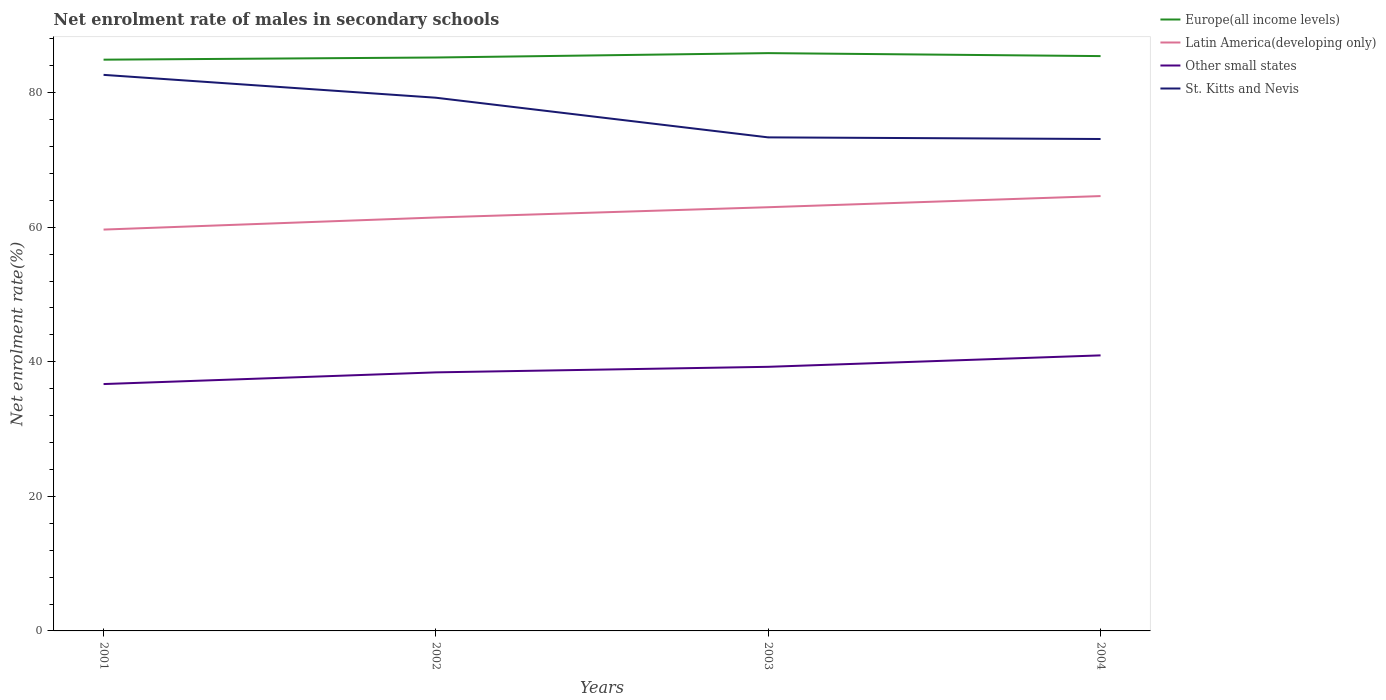Across all years, what is the maximum net enrolment rate of males in secondary schools in Other small states?
Provide a short and direct response. 36.69. In which year was the net enrolment rate of males in secondary schools in St. Kitts and Nevis maximum?
Offer a terse response. 2004. What is the total net enrolment rate of males in secondary schools in Latin America(developing only) in the graph?
Ensure brevity in your answer.  -1.66. What is the difference between the highest and the second highest net enrolment rate of males in secondary schools in Latin America(developing only)?
Your answer should be very brief. 4.98. What is the difference between the highest and the lowest net enrolment rate of males in secondary schools in Other small states?
Provide a short and direct response. 2. Is the net enrolment rate of males in secondary schools in Other small states strictly greater than the net enrolment rate of males in secondary schools in Europe(all income levels) over the years?
Your answer should be compact. Yes. How many lines are there?
Offer a very short reply. 4. How many years are there in the graph?
Give a very brief answer. 4. What is the difference between two consecutive major ticks on the Y-axis?
Keep it short and to the point. 20. Does the graph contain grids?
Provide a short and direct response. No. Where does the legend appear in the graph?
Keep it short and to the point. Top right. How are the legend labels stacked?
Give a very brief answer. Vertical. What is the title of the graph?
Give a very brief answer. Net enrolment rate of males in secondary schools. What is the label or title of the Y-axis?
Make the answer very short. Net enrolment rate(%). What is the Net enrolment rate(%) of Europe(all income levels) in 2001?
Give a very brief answer. 84.9. What is the Net enrolment rate(%) of Latin America(developing only) in 2001?
Your answer should be compact. 59.65. What is the Net enrolment rate(%) of Other small states in 2001?
Provide a succinct answer. 36.69. What is the Net enrolment rate(%) of St. Kitts and Nevis in 2001?
Provide a succinct answer. 82.65. What is the Net enrolment rate(%) of Europe(all income levels) in 2002?
Provide a succinct answer. 85.23. What is the Net enrolment rate(%) of Latin America(developing only) in 2002?
Give a very brief answer. 61.45. What is the Net enrolment rate(%) in Other small states in 2002?
Make the answer very short. 38.43. What is the Net enrolment rate(%) of St. Kitts and Nevis in 2002?
Your response must be concise. 79.25. What is the Net enrolment rate(%) of Europe(all income levels) in 2003?
Your answer should be compact. 85.88. What is the Net enrolment rate(%) of Latin America(developing only) in 2003?
Keep it short and to the point. 62.97. What is the Net enrolment rate(%) of Other small states in 2003?
Provide a succinct answer. 39.26. What is the Net enrolment rate(%) in St. Kitts and Nevis in 2003?
Your response must be concise. 73.36. What is the Net enrolment rate(%) of Europe(all income levels) in 2004?
Provide a short and direct response. 85.44. What is the Net enrolment rate(%) of Latin America(developing only) in 2004?
Give a very brief answer. 64.63. What is the Net enrolment rate(%) in Other small states in 2004?
Ensure brevity in your answer.  40.96. What is the Net enrolment rate(%) in St. Kitts and Nevis in 2004?
Your answer should be very brief. 73.11. Across all years, what is the maximum Net enrolment rate(%) in Europe(all income levels)?
Offer a very short reply. 85.88. Across all years, what is the maximum Net enrolment rate(%) in Latin America(developing only)?
Make the answer very short. 64.63. Across all years, what is the maximum Net enrolment rate(%) in Other small states?
Your answer should be very brief. 40.96. Across all years, what is the maximum Net enrolment rate(%) of St. Kitts and Nevis?
Provide a short and direct response. 82.65. Across all years, what is the minimum Net enrolment rate(%) in Europe(all income levels)?
Your answer should be compact. 84.9. Across all years, what is the minimum Net enrolment rate(%) of Latin America(developing only)?
Your answer should be very brief. 59.65. Across all years, what is the minimum Net enrolment rate(%) in Other small states?
Give a very brief answer. 36.69. Across all years, what is the minimum Net enrolment rate(%) in St. Kitts and Nevis?
Your response must be concise. 73.11. What is the total Net enrolment rate(%) in Europe(all income levels) in the graph?
Your response must be concise. 341.45. What is the total Net enrolment rate(%) in Latin America(developing only) in the graph?
Ensure brevity in your answer.  248.71. What is the total Net enrolment rate(%) in Other small states in the graph?
Your response must be concise. 155.33. What is the total Net enrolment rate(%) in St. Kitts and Nevis in the graph?
Your answer should be compact. 308.37. What is the difference between the Net enrolment rate(%) of Europe(all income levels) in 2001 and that in 2002?
Your response must be concise. -0.32. What is the difference between the Net enrolment rate(%) of Latin America(developing only) in 2001 and that in 2002?
Make the answer very short. -1.8. What is the difference between the Net enrolment rate(%) in Other small states in 2001 and that in 2002?
Provide a succinct answer. -1.74. What is the difference between the Net enrolment rate(%) in St. Kitts and Nevis in 2001 and that in 2002?
Provide a succinct answer. 3.4. What is the difference between the Net enrolment rate(%) in Europe(all income levels) in 2001 and that in 2003?
Your answer should be compact. -0.97. What is the difference between the Net enrolment rate(%) of Latin America(developing only) in 2001 and that in 2003?
Keep it short and to the point. -3.32. What is the difference between the Net enrolment rate(%) in Other small states in 2001 and that in 2003?
Ensure brevity in your answer.  -2.56. What is the difference between the Net enrolment rate(%) of St. Kitts and Nevis in 2001 and that in 2003?
Your answer should be very brief. 9.29. What is the difference between the Net enrolment rate(%) of Europe(all income levels) in 2001 and that in 2004?
Make the answer very short. -0.53. What is the difference between the Net enrolment rate(%) of Latin America(developing only) in 2001 and that in 2004?
Offer a terse response. -4.98. What is the difference between the Net enrolment rate(%) in Other small states in 2001 and that in 2004?
Give a very brief answer. -4.26. What is the difference between the Net enrolment rate(%) in St. Kitts and Nevis in 2001 and that in 2004?
Make the answer very short. 9.53. What is the difference between the Net enrolment rate(%) of Europe(all income levels) in 2002 and that in 2003?
Keep it short and to the point. -0.65. What is the difference between the Net enrolment rate(%) of Latin America(developing only) in 2002 and that in 2003?
Ensure brevity in your answer.  -1.52. What is the difference between the Net enrolment rate(%) in Other small states in 2002 and that in 2003?
Keep it short and to the point. -0.83. What is the difference between the Net enrolment rate(%) of St. Kitts and Nevis in 2002 and that in 2003?
Your answer should be compact. 5.89. What is the difference between the Net enrolment rate(%) in Europe(all income levels) in 2002 and that in 2004?
Keep it short and to the point. -0.21. What is the difference between the Net enrolment rate(%) in Latin America(developing only) in 2002 and that in 2004?
Provide a succinct answer. -3.18. What is the difference between the Net enrolment rate(%) of Other small states in 2002 and that in 2004?
Keep it short and to the point. -2.53. What is the difference between the Net enrolment rate(%) of St. Kitts and Nevis in 2002 and that in 2004?
Give a very brief answer. 6.14. What is the difference between the Net enrolment rate(%) of Europe(all income levels) in 2003 and that in 2004?
Give a very brief answer. 0.44. What is the difference between the Net enrolment rate(%) in Latin America(developing only) in 2003 and that in 2004?
Keep it short and to the point. -1.66. What is the difference between the Net enrolment rate(%) of Other small states in 2003 and that in 2004?
Your answer should be very brief. -1.7. What is the difference between the Net enrolment rate(%) in St. Kitts and Nevis in 2003 and that in 2004?
Keep it short and to the point. 0.24. What is the difference between the Net enrolment rate(%) of Europe(all income levels) in 2001 and the Net enrolment rate(%) of Latin America(developing only) in 2002?
Provide a short and direct response. 23.45. What is the difference between the Net enrolment rate(%) of Europe(all income levels) in 2001 and the Net enrolment rate(%) of Other small states in 2002?
Give a very brief answer. 46.48. What is the difference between the Net enrolment rate(%) of Europe(all income levels) in 2001 and the Net enrolment rate(%) of St. Kitts and Nevis in 2002?
Make the answer very short. 5.66. What is the difference between the Net enrolment rate(%) in Latin America(developing only) in 2001 and the Net enrolment rate(%) in Other small states in 2002?
Provide a succinct answer. 21.22. What is the difference between the Net enrolment rate(%) of Latin America(developing only) in 2001 and the Net enrolment rate(%) of St. Kitts and Nevis in 2002?
Ensure brevity in your answer.  -19.6. What is the difference between the Net enrolment rate(%) of Other small states in 2001 and the Net enrolment rate(%) of St. Kitts and Nevis in 2002?
Ensure brevity in your answer.  -42.56. What is the difference between the Net enrolment rate(%) of Europe(all income levels) in 2001 and the Net enrolment rate(%) of Latin America(developing only) in 2003?
Your answer should be compact. 21.93. What is the difference between the Net enrolment rate(%) of Europe(all income levels) in 2001 and the Net enrolment rate(%) of Other small states in 2003?
Offer a terse response. 45.65. What is the difference between the Net enrolment rate(%) of Europe(all income levels) in 2001 and the Net enrolment rate(%) of St. Kitts and Nevis in 2003?
Offer a terse response. 11.55. What is the difference between the Net enrolment rate(%) in Latin America(developing only) in 2001 and the Net enrolment rate(%) in Other small states in 2003?
Offer a very short reply. 20.4. What is the difference between the Net enrolment rate(%) of Latin America(developing only) in 2001 and the Net enrolment rate(%) of St. Kitts and Nevis in 2003?
Provide a short and direct response. -13.7. What is the difference between the Net enrolment rate(%) of Other small states in 2001 and the Net enrolment rate(%) of St. Kitts and Nevis in 2003?
Provide a succinct answer. -36.66. What is the difference between the Net enrolment rate(%) in Europe(all income levels) in 2001 and the Net enrolment rate(%) in Latin America(developing only) in 2004?
Your response must be concise. 20.27. What is the difference between the Net enrolment rate(%) in Europe(all income levels) in 2001 and the Net enrolment rate(%) in Other small states in 2004?
Your answer should be compact. 43.95. What is the difference between the Net enrolment rate(%) in Europe(all income levels) in 2001 and the Net enrolment rate(%) in St. Kitts and Nevis in 2004?
Your answer should be compact. 11.79. What is the difference between the Net enrolment rate(%) of Latin America(developing only) in 2001 and the Net enrolment rate(%) of Other small states in 2004?
Ensure brevity in your answer.  18.7. What is the difference between the Net enrolment rate(%) in Latin America(developing only) in 2001 and the Net enrolment rate(%) in St. Kitts and Nevis in 2004?
Keep it short and to the point. -13.46. What is the difference between the Net enrolment rate(%) of Other small states in 2001 and the Net enrolment rate(%) of St. Kitts and Nevis in 2004?
Ensure brevity in your answer.  -36.42. What is the difference between the Net enrolment rate(%) in Europe(all income levels) in 2002 and the Net enrolment rate(%) in Latin America(developing only) in 2003?
Make the answer very short. 22.25. What is the difference between the Net enrolment rate(%) in Europe(all income levels) in 2002 and the Net enrolment rate(%) in Other small states in 2003?
Give a very brief answer. 45.97. What is the difference between the Net enrolment rate(%) of Europe(all income levels) in 2002 and the Net enrolment rate(%) of St. Kitts and Nevis in 2003?
Your answer should be compact. 11.87. What is the difference between the Net enrolment rate(%) in Latin America(developing only) in 2002 and the Net enrolment rate(%) in Other small states in 2003?
Offer a very short reply. 22.19. What is the difference between the Net enrolment rate(%) of Latin America(developing only) in 2002 and the Net enrolment rate(%) of St. Kitts and Nevis in 2003?
Your answer should be very brief. -11.91. What is the difference between the Net enrolment rate(%) of Other small states in 2002 and the Net enrolment rate(%) of St. Kitts and Nevis in 2003?
Give a very brief answer. -34.93. What is the difference between the Net enrolment rate(%) in Europe(all income levels) in 2002 and the Net enrolment rate(%) in Latin America(developing only) in 2004?
Your answer should be compact. 20.6. What is the difference between the Net enrolment rate(%) of Europe(all income levels) in 2002 and the Net enrolment rate(%) of Other small states in 2004?
Provide a succinct answer. 44.27. What is the difference between the Net enrolment rate(%) of Europe(all income levels) in 2002 and the Net enrolment rate(%) of St. Kitts and Nevis in 2004?
Your response must be concise. 12.11. What is the difference between the Net enrolment rate(%) of Latin America(developing only) in 2002 and the Net enrolment rate(%) of Other small states in 2004?
Ensure brevity in your answer.  20.5. What is the difference between the Net enrolment rate(%) of Latin America(developing only) in 2002 and the Net enrolment rate(%) of St. Kitts and Nevis in 2004?
Offer a terse response. -11.66. What is the difference between the Net enrolment rate(%) in Other small states in 2002 and the Net enrolment rate(%) in St. Kitts and Nevis in 2004?
Your answer should be compact. -34.68. What is the difference between the Net enrolment rate(%) of Europe(all income levels) in 2003 and the Net enrolment rate(%) of Latin America(developing only) in 2004?
Your answer should be compact. 21.25. What is the difference between the Net enrolment rate(%) of Europe(all income levels) in 2003 and the Net enrolment rate(%) of Other small states in 2004?
Keep it short and to the point. 44.92. What is the difference between the Net enrolment rate(%) of Europe(all income levels) in 2003 and the Net enrolment rate(%) of St. Kitts and Nevis in 2004?
Offer a terse response. 12.76. What is the difference between the Net enrolment rate(%) of Latin America(developing only) in 2003 and the Net enrolment rate(%) of Other small states in 2004?
Ensure brevity in your answer.  22.02. What is the difference between the Net enrolment rate(%) in Latin America(developing only) in 2003 and the Net enrolment rate(%) in St. Kitts and Nevis in 2004?
Offer a very short reply. -10.14. What is the difference between the Net enrolment rate(%) in Other small states in 2003 and the Net enrolment rate(%) in St. Kitts and Nevis in 2004?
Offer a terse response. -33.86. What is the average Net enrolment rate(%) in Europe(all income levels) per year?
Your answer should be very brief. 85.36. What is the average Net enrolment rate(%) of Latin America(developing only) per year?
Keep it short and to the point. 62.18. What is the average Net enrolment rate(%) in Other small states per year?
Your answer should be very brief. 38.83. What is the average Net enrolment rate(%) in St. Kitts and Nevis per year?
Make the answer very short. 77.09. In the year 2001, what is the difference between the Net enrolment rate(%) in Europe(all income levels) and Net enrolment rate(%) in Latin America(developing only)?
Your response must be concise. 25.25. In the year 2001, what is the difference between the Net enrolment rate(%) in Europe(all income levels) and Net enrolment rate(%) in Other small states?
Offer a terse response. 48.21. In the year 2001, what is the difference between the Net enrolment rate(%) of Europe(all income levels) and Net enrolment rate(%) of St. Kitts and Nevis?
Your answer should be compact. 2.26. In the year 2001, what is the difference between the Net enrolment rate(%) in Latin America(developing only) and Net enrolment rate(%) in Other small states?
Your response must be concise. 22.96. In the year 2001, what is the difference between the Net enrolment rate(%) in Latin America(developing only) and Net enrolment rate(%) in St. Kitts and Nevis?
Give a very brief answer. -23. In the year 2001, what is the difference between the Net enrolment rate(%) in Other small states and Net enrolment rate(%) in St. Kitts and Nevis?
Your response must be concise. -45.96. In the year 2002, what is the difference between the Net enrolment rate(%) of Europe(all income levels) and Net enrolment rate(%) of Latin America(developing only)?
Your response must be concise. 23.78. In the year 2002, what is the difference between the Net enrolment rate(%) in Europe(all income levels) and Net enrolment rate(%) in Other small states?
Provide a short and direct response. 46.8. In the year 2002, what is the difference between the Net enrolment rate(%) of Europe(all income levels) and Net enrolment rate(%) of St. Kitts and Nevis?
Make the answer very short. 5.98. In the year 2002, what is the difference between the Net enrolment rate(%) of Latin America(developing only) and Net enrolment rate(%) of Other small states?
Your answer should be compact. 23.02. In the year 2002, what is the difference between the Net enrolment rate(%) of Latin America(developing only) and Net enrolment rate(%) of St. Kitts and Nevis?
Your answer should be very brief. -17.8. In the year 2002, what is the difference between the Net enrolment rate(%) in Other small states and Net enrolment rate(%) in St. Kitts and Nevis?
Your response must be concise. -40.82. In the year 2003, what is the difference between the Net enrolment rate(%) of Europe(all income levels) and Net enrolment rate(%) of Latin America(developing only)?
Your answer should be very brief. 22.9. In the year 2003, what is the difference between the Net enrolment rate(%) of Europe(all income levels) and Net enrolment rate(%) of Other small states?
Your response must be concise. 46.62. In the year 2003, what is the difference between the Net enrolment rate(%) of Europe(all income levels) and Net enrolment rate(%) of St. Kitts and Nevis?
Make the answer very short. 12.52. In the year 2003, what is the difference between the Net enrolment rate(%) in Latin America(developing only) and Net enrolment rate(%) in Other small states?
Your answer should be very brief. 23.72. In the year 2003, what is the difference between the Net enrolment rate(%) in Latin America(developing only) and Net enrolment rate(%) in St. Kitts and Nevis?
Make the answer very short. -10.38. In the year 2003, what is the difference between the Net enrolment rate(%) of Other small states and Net enrolment rate(%) of St. Kitts and Nevis?
Offer a very short reply. -34.1. In the year 2004, what is the difference between the Net enrolment rate(%) in Europe(all income levels) and Net enrolment rate(%) in Latin America(developing only)?
Keep it short and to the point. 20.81. In the year 2004, what is the difference between the Net enrolment rate(%) in Europe(all income levels) and Net enrolment rate(%) in Other small states?
Ensure brevity in your answer.  44.48. In the year 2004, what is the difference between the Net enrolment rate(%) in Europe(all income levels) and Net enrolment rate(%) in St. Kitts and Nevis?
Your answer should be very brief. 12.32. In the year 2004, what is the difference between the Net enrolment rate(%) in Latin America(developing only) and Net enrolment rate(%) in Other small states?
Ensure brevity in your answer.  23.68. In the year 2004, what is the difference between the Net enrolment rate(%) in Latin America(developing only) and Net enrolment rate(%) in St. Kitts and Nevis?
Provide a short and direct response. -8.48. In the year 2004, what is the difference between the Net enrolment rate(%) of Other small states and Net enrolment rate(%) of St. Kitts and Nevis?
Offer a very short reply. -32.16. What is the ratio of the Net enrolment rate(%) of Europe(all income levels) in 2001 to that in 2002?
Your answer should be very brief. 1. What is the ratio of the Net enrolment rate(%) in Latin America(developing only) in 2001 to that in 2002?
Provide a succinct answer. 0.97. What is the ratio of the Net enrolment rate(%) in Other small states in 2001 to that in 2002?
Offer a very short reply. 0.95. What is the ratio of the Net enrolment rate(%) in St. Kitts and Nevis in 2001 to that in 2002?
Your answer should be compact. 1.04. What is the ratio of the Net enrolment rate(%) of Europe(all income levels) in 2001 to that in 2003?
Provide a succinct answer. 0.99. What is the ratio of the Net enrolment rate(%) in Latin America(developing only) in 2001 to that in 2003?
Ensure brevity in your answer.  0.95. What is the ratio of the Net enrolment rate(%) of Other small states in 2001 to that in 2003?
Ensure brevity in your answer.  0.93. What is the ratio of the Net enrolment rate(%) in St. Kitts and Nevis in 2001 to that in 2003?
Provide a succinct answer. 1.13. What is the ratio of the Net enrolment rate(%) in Europe(all income levels) in 2001 to that in 2004?
Offer a very short reply. 0.99. What is the ratio of the Net enrolment rate(%) in Latin America(developing only) in 2001 to that in 2004?
Keep it short and to the point. 0.92. What is the ratio of the Net enrolment rate(%) of Other small states in 2001 to that in 2004?
Offer a terse response. 0.9. What is the ratio of the Net enrolment rate(%) of St. Kitts and Nevis in 2001 to that in 2004?
Offer a terse response. 1.13. What is the ratio of the Net enrolment rate(%) in Europe(all income levels) in 2002 to that in 2003?
Offer a very short reply. 0.99. What is the ratio of the Net enrolment rate(%) in Latin America(developing only) in 2002 to that in 2003?
Ensure brevity in your answer.  0.98. What is the ratio of the Net enrolment rate(%) in Other small states in 2002 to that in 2003?
Give a very brief answer. 0.98. What is the ratio of the Net enrolment rate(%) in St. Kitts and Nevis in 2002 to that in 2003?
Offer a terse response. 1.08. What is the ratio of the Net enrolment rate(%) of Europe(all income levels) in 2002 to that in 2004?
Make the answer very short. 1. What is the ratio of the Net enrolment rate(%) of Latin America(developing only) in 2002 to that in 2004?
Offer a terse response. 0.95. What is the ratio of the Net enrolment rate(%) of Other small states in 2002 to that in 2004?
Your answer should be compact. 0.94. What is the ratio of the Net enrolment rate(%) in St. Kitts and Nevis in 2002 to that in 2004?
Offer a very short reply. 1.08. What is the ratio of the Net enrolment rate(%) of Europe(all income levels) in 2003 to that in 2004?
Give a very brief answer. 1.01. What is the ratio of the Net enrolment rate(%) in Latin America(developing only) in 2003 to that in 2004?
Provide a short and direct response. 0.97. What is the ratio of the Net enrolment rate(%) in Other small states in 2003 to that in 2004?
Give a very brief answer. 0.96. What is the difference between the highest and the second highest Net enrolment rate(%) of Europe(all income levels)?
Give a very brief answer. 0.44. What is the difference between the highest and the second highest Net enrolment rate(%) in Latin America(developing only)?
Give a very brief answer. 1.66. What is the difference between the highest and the second highest Net enrolment rate(%) in Other small states?
Make the answer very short. 1.7. What is the difference between the highest and the second highest Net enrolment rate(%) of St. Kitts and Nevis?
Keep it short and to the point. 3.4. What is the difference between the highest and the lowest Net enrolment rate(%) in Europe(all income levels)?
Offer a very short reply. 0.97. What is the difference between the highest and the lowest Net enrolment rate(%) of Latin America(developing only)?
Your response must be concise. 4.98. What is the difference between the highest and the lowest Net enrolment rate(%) of Other small states?
Your answer should be compact. 4.26. What is the difference between the highest and the lowest Net enrolment rate(%) in St. Kitts and Nevis?
Keep it short and to the point. 9.53. 